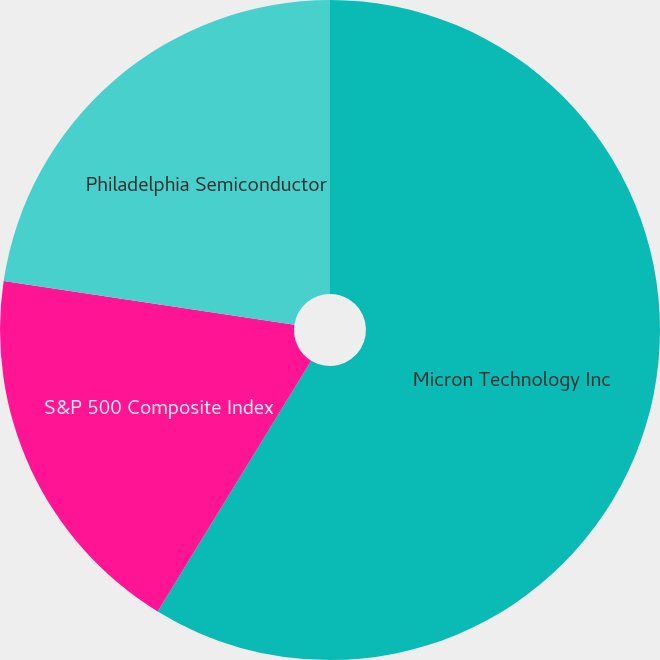<chart> <loc_0><loc_0><loc_500><loc_500><pie_chart><fcel>Micron Technology Inc<fcel>S&P 500 Composite Index<fcel>Philadelphia Semiconductor<nl><fcel>58.74%<fcel>18.62%<fcel>22.63%<nl></chart> 